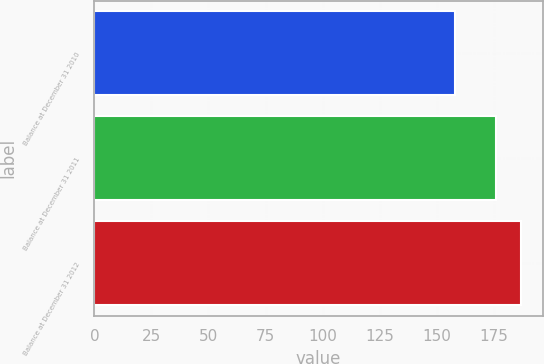Convert chart to OTSL. <chart><loc_0><loc_0><loc_500><loc_500><bar_chart><fcel>Balance at December 31 2010<fcel>Balance at December 31 2011<fcel>Balance at December 31 2012<nl><fcel>158<fcel>176<fcel>187<nl></chart> 